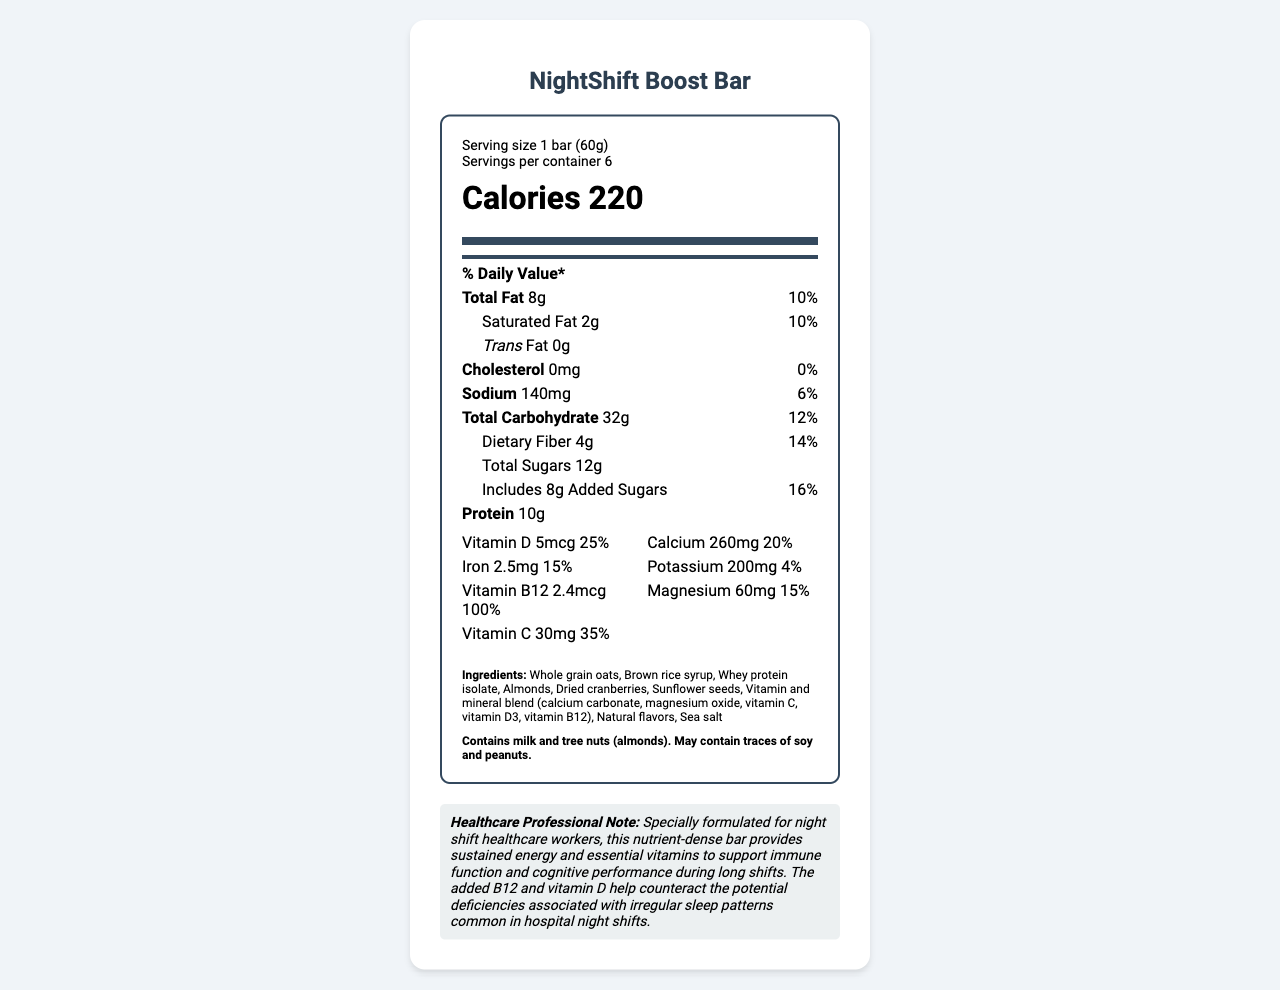what is the serving size? The serving size is explicitly mentioned in the serving information section at the top of the nutrition label.
Answer: 1 bar (60g) how many servings are there in one container? The number of servings per container is clearly stated in the serving information section.
Answer: 6 how many grams of protein are in one bar? The amount of protein per bar is listed under the nutrient section.
Answer: 10g What is the daily value percentage for Vitamin D in a bar? The daily value percentage for Vitamin D is listed in the vitamin section.
Answer: 25% what is the amount of dietary fiber per bar? The amount of dietary fiber per bar is stated in the nutrient section.
Answer: 4g how many grams of added sugars are there in one bar? The amount of added sugars is mentioned under the total sugars section in the nutrient breakdown.
Answer: 8g Which ingredient is not mentioned in the ingredients list? A. Sunflower seeds B. Cocoa butter C. Almonds The ingredients list does not include cocoa butter, but it does include sunflower seeds and almonds.
Answer: B. Cocoa butter What is the % daily value of calcium provided by one bar? A. 15% B. 25% C. 20% D. 35% The % daily value of calcium provided by one bar is stated as 20% in the vitamin section.
Answer: C. 20% Does the bar contain any tree nuts? The allergen information mentions that the bar contains tree nuts (almonds).
Answer: Yes Summarize the purpose of the NightShift Boost Bar. The summary merges details from the healthcare professional note with main ingredients and nutrient contributions for an overall understanding of the bar's purpose.
Answer: The NightShift Boost Bar is a vitamin-fortified snack bar designed for night shift healthcare workers. It provides sustained energy and essential vitamins to support immune function and cognitive performance during long shifts. The bar includes Vitamin B12 and Vitamin D to help counteract potential deficiencies related to irregular sleep patterns commonly experienced by night shift workers. Is the sodium content relatively low? The sodium content in one bar is 140mg, which is 6% of the daily value, indicating it is relatively low.
Answer: Yes Can a person with a soy allergy safely consume this bar? The allergen information mentions that the bar may contain traces of soy, so a person with a soy allergy should be cautious.
Answer: Not enough information Would this bar be suitable for someone looking to increase their dietary fiber intake? The bar contains 4g of dietary fiber per serving, which is 14% of the daily value, making it suitable for those looking to increase their fiber intake.
Answer: Yes 